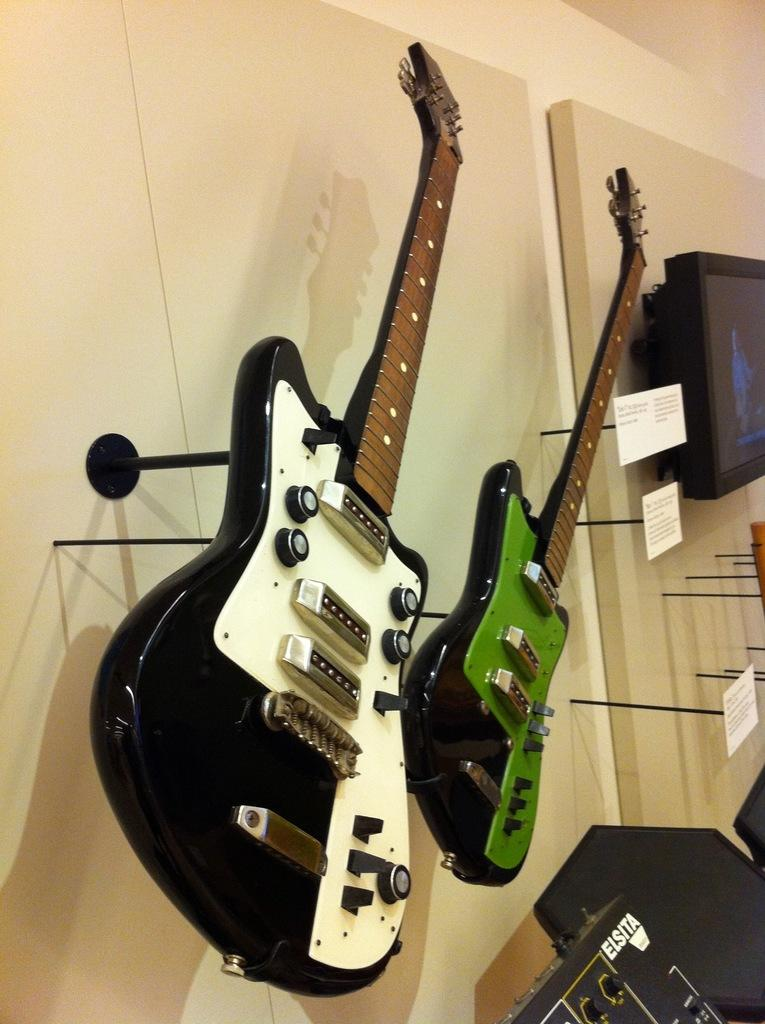What musical instruments are hanging on the wall in the image? There are guitars hanging on the wall in the image. What can be seen on the right side of the image? There is a screen on the right side of the image. What type of objects are visible in the image? Papers are visible in the image. What is in the background of the image? There is a wall in the background of the image. Where are the cows located in the image? There are no cows present in the image. What type of meeting is taking place in the image? There is no meeting depicted in the image. 